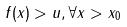<formula> <loc_0><loc_0><loc_500><loc_500>f ( x ) > u , \forall x > x _ { 0 }</formula> 